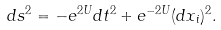<formula> <loc_0><loc_0><loc_500><loc_500>d s ^ { 2 } = - e ^ { 2 U } d t ^ { 2 } + e ^ { - 2 U } ( d x _ { i } ) ^ { 2 } .</formula> 